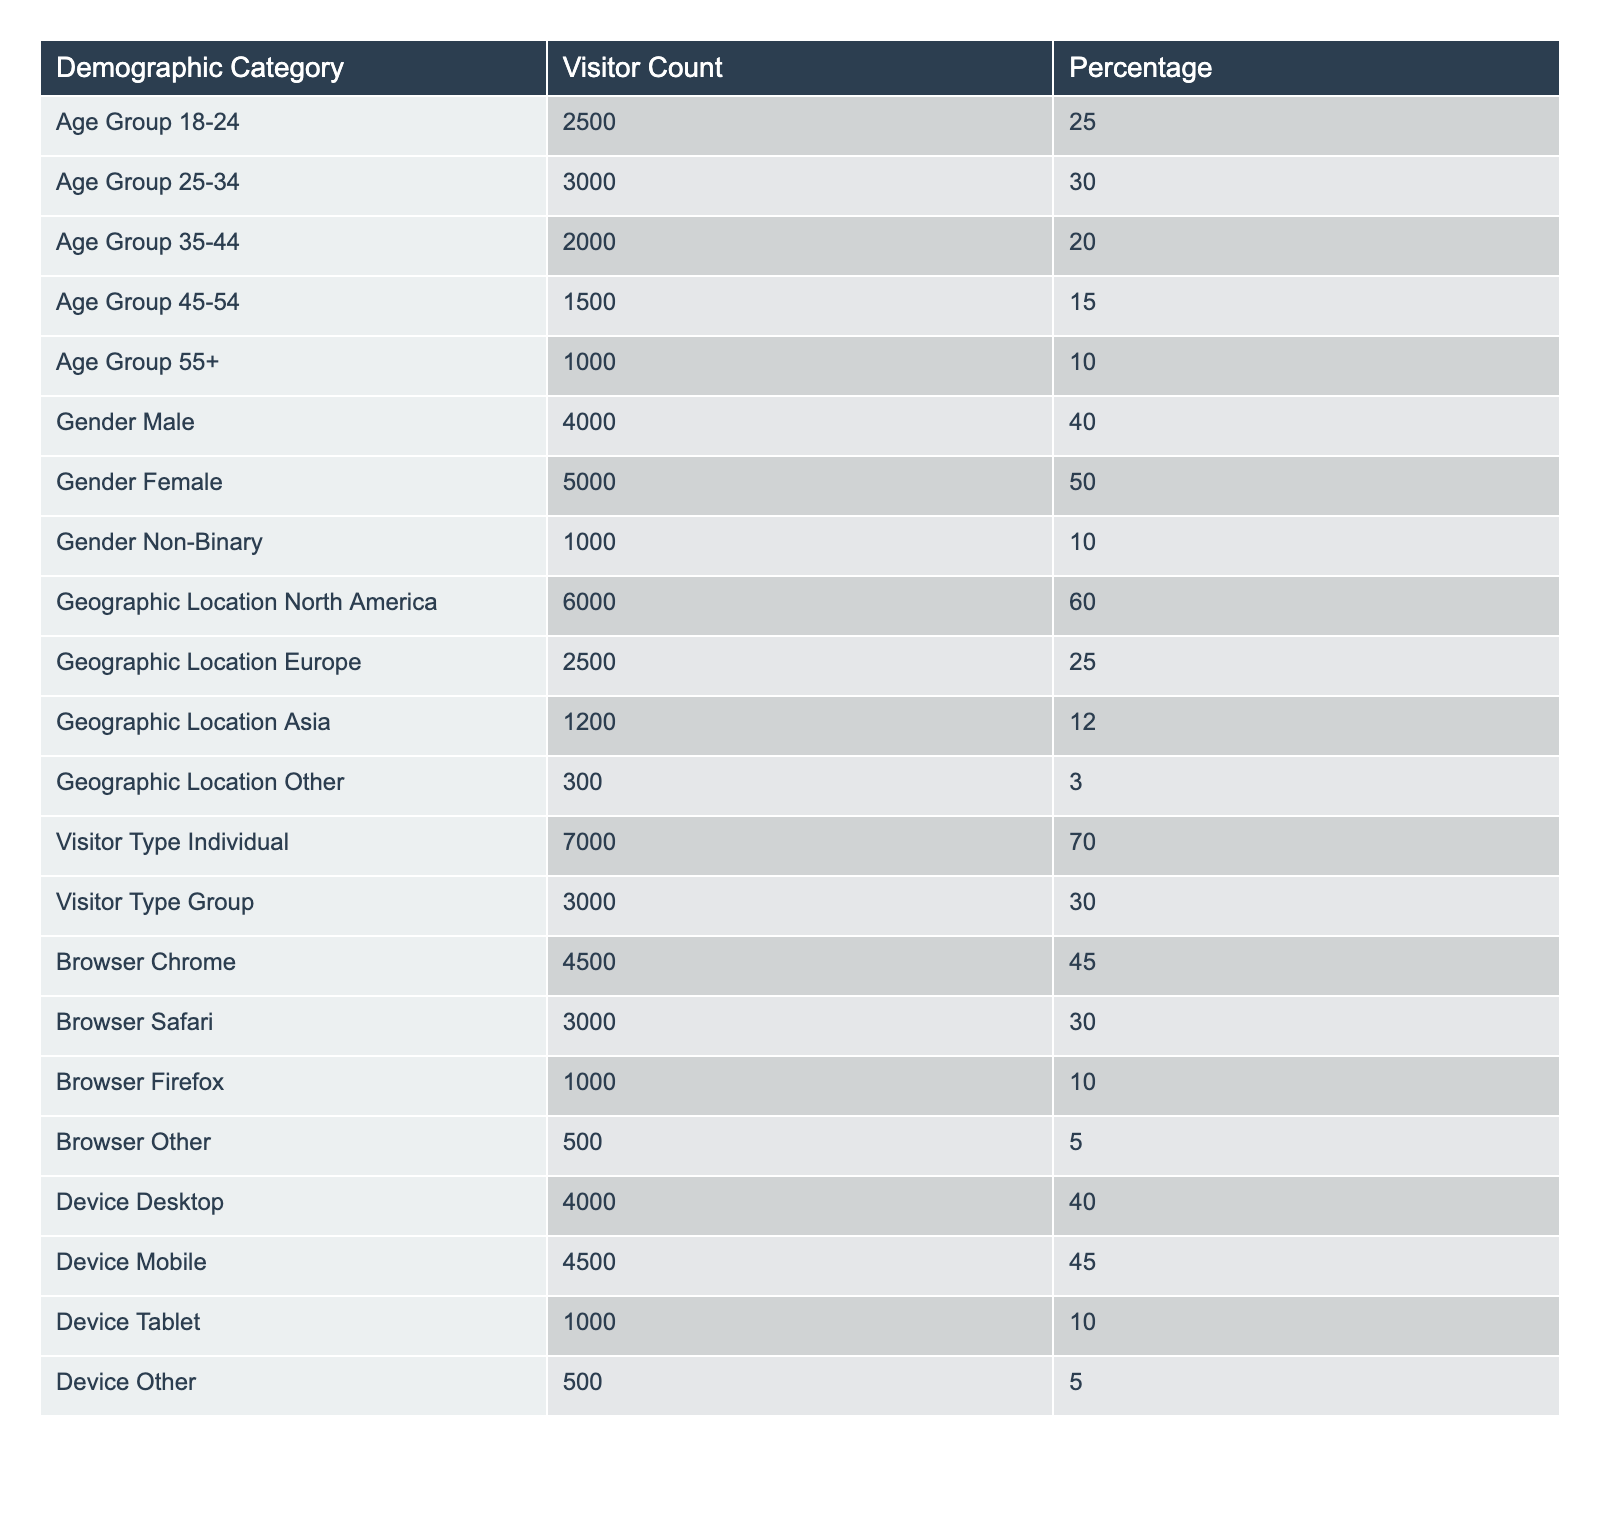What is the visitor count for the age group 25-34? The table shows the demographic category "Age Group 25-34" with a visitor count of 3000.
Answer: 3000 What percentage of visitors are female? According to the table, the "Gender Female" category shows a percentage of 50%.
Answer: 50% What is the total visitor count for the age groups 35-44 and 45-54 combined? Adding the visitor counts from the table for age groups 35-44 (2000) and 45-54 (1500) gives 2000 + 1500 = 3500.
Answer: 3500 How many more individual visitors are there compared to group visitors? The table lists 7000 individual visitors and 3000 group visitors. The difference is 7000 - 3000 = 4000.
Answer: 4000 What percentage of visitors come from North America? The table indicates that 60% of visitors are from North America.
Answer: 60% Is the number of male visitors greater than the number of female visitors? The table specifies 4000 male visitors and 5000 female visitors, so 4000 is not greater than 5000.
Answer: No What is the average visitor percentage of the age groups 55 and above? The percentage for the age group 55+ is 10%. To find the average, only this group is considered, hence the average is also 10%.
Answer: 10% Which geographic location has the least number of visitors? The "Geographic Location Other" category has the lowest visitor count of 300.
Answer: 300 What is the total number of visitors from Europe and Asia? The total visitor counts from Europe (2500) and Asia (1200) are summed: 2500 + 1200 = 3700.
Answer: 3700 What device type is used by the least number of visitors? The "Device Other" category has the lowest visitor count of 500, which is mentioned in the table.
Answer: 500 What percentage of visitors use mobile devices compared to those using desktop devices? The table shows 4500 visitors use mobile devices (45%) and 4000 use desktop devices (40%). The percentage of mobile is higher: 45% compared to 40%.
Answer: Yes If we combine the counts for male and non-binary visitors, how does it compare to female visitors? The counts for male (4000) plus non-binary (1000) yield 5000, which is equal to the female count of 5000.
Answer: Equal 